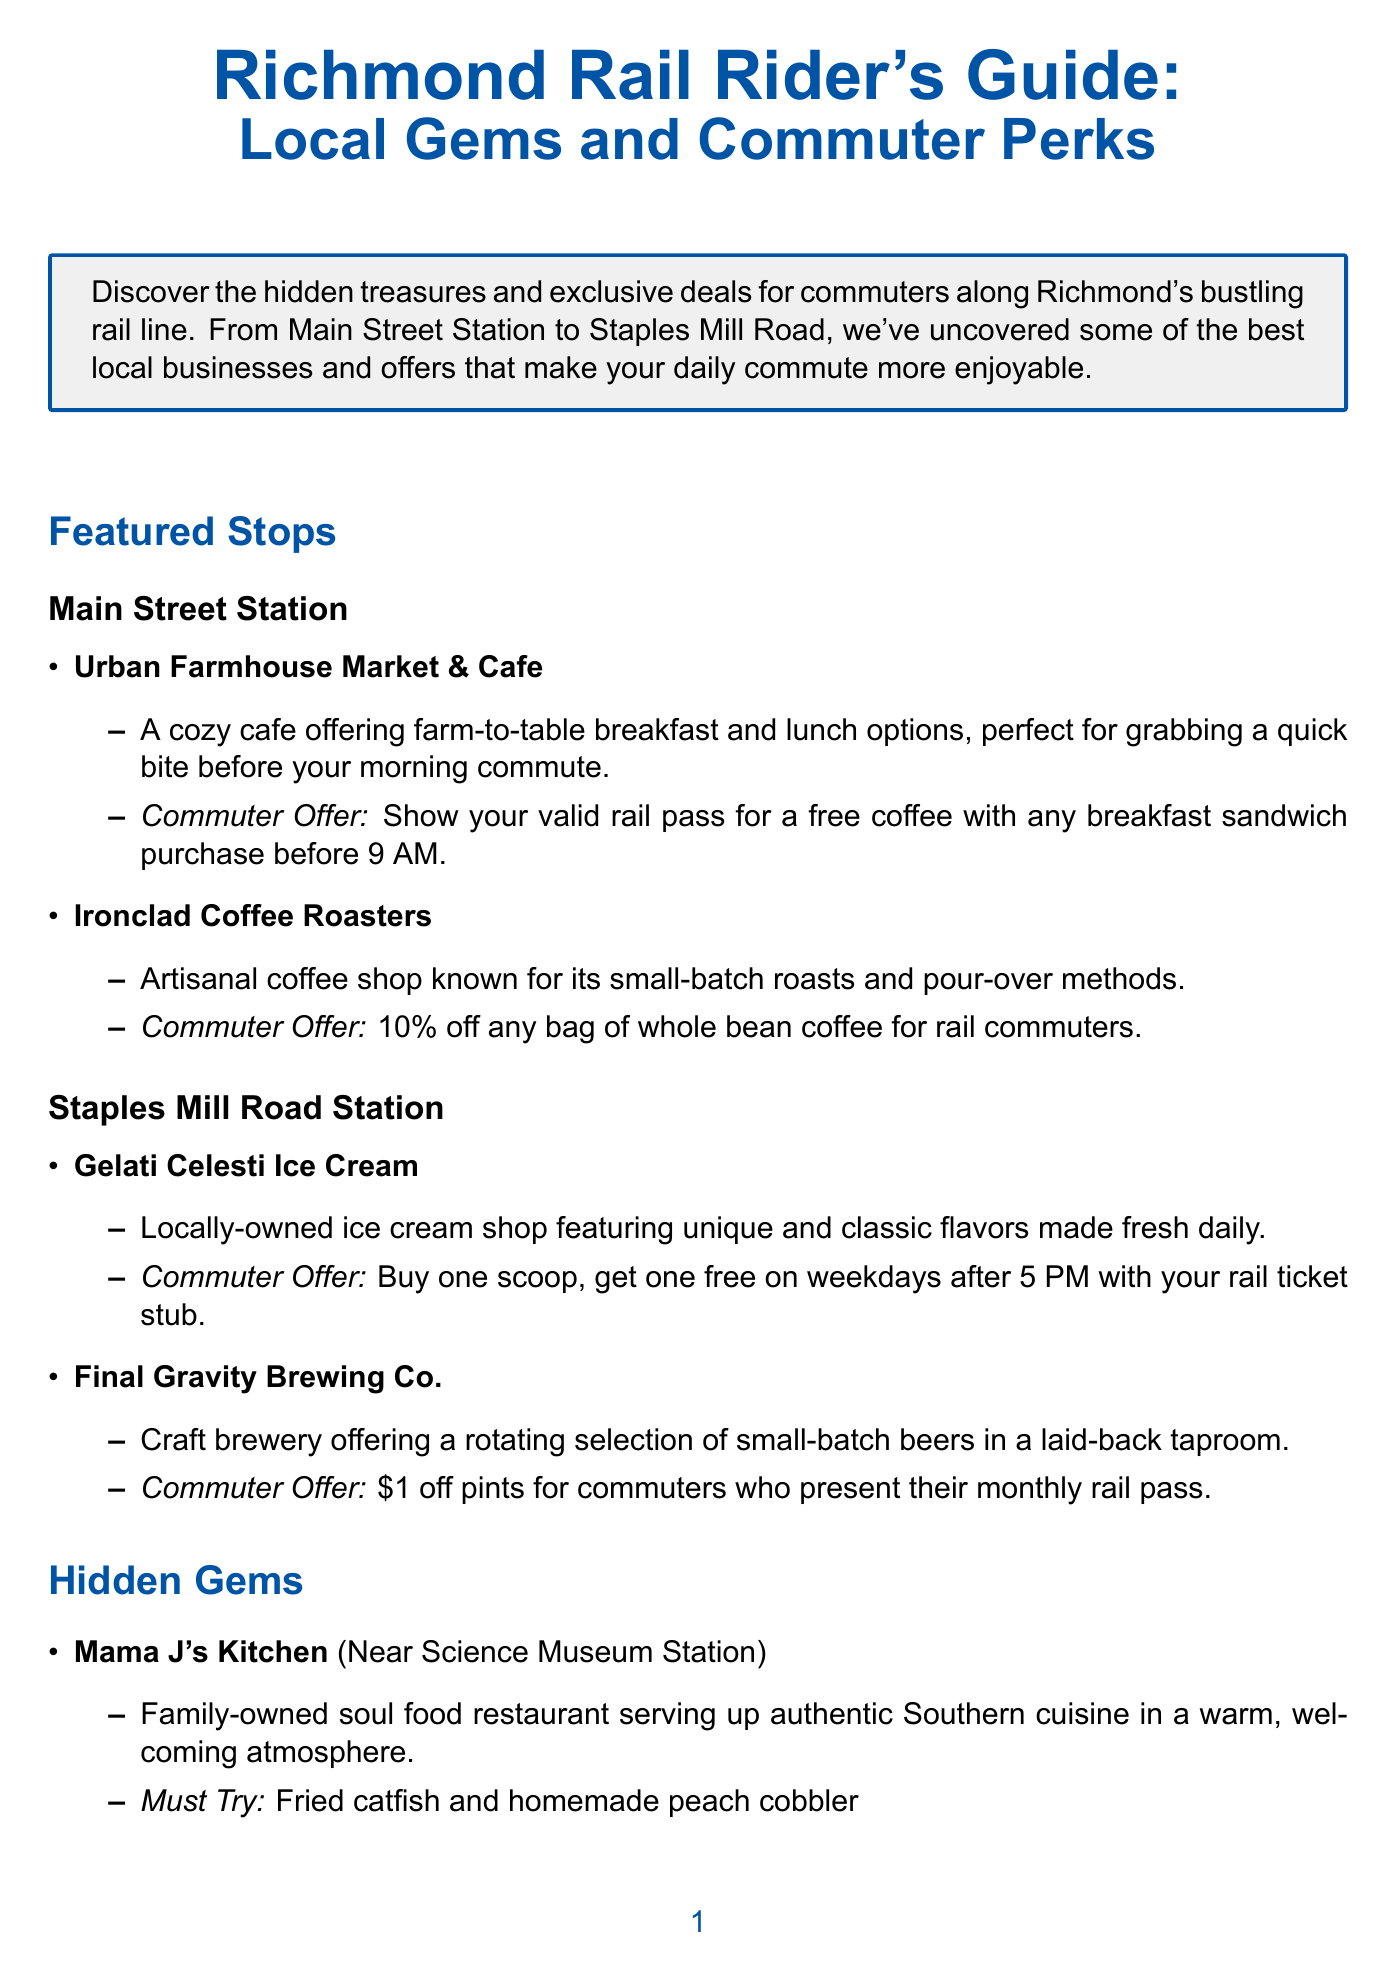What is the title of the newsletter? The title is a specific piece of information that provides the main theme of the document.
Answer: Richmond Rail Rider's Guide: Local Gems and Commuter Perks What is the commuter offer at Urban Farmhouse Market & Cafe? The commuter offer outlines the specific deal available for commuters at this cafe.
Answer: Free coffee with any breakfast sandwich purchase before 9 AM Which station is near Mama J's Kitchen? The location of Mama J's Kitchen is specified in relation to a rail station.
Answer: Science Museum Station What unique flavor does Gelati Celesti Ice Cream offer? This question requires understanding which type of products the ice cream shop specializes in.
Answer: Unique and classic flavors When does the Richmond Folk Festival occur? The date of the event is a key information provided in the document.
Answer: October 8-10, 2023 What is one reason to download the GRTC mobile app? This question relates to the commuter tips segment, requiring reasoning about its purpose.
Answer: Real-time updates on train schedules What is a must-try dish at Perly's Restaurant & Delicatessen? This asks for a specific recommended dish mentioned in the hidden gems section.
Answer: The 'Benny Goodman' pastrami sandwich What kind of brewery is Final Gravity Brewing Co.? This question requires understanding the type of business mentioned in the document.
Answer: Craft brewery 